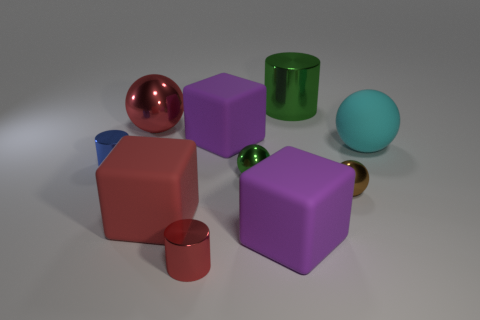Can you describe the lighting in the scene? The scene is lit by a soft, diffused light source from above, creating gentle shadows beneath the objects, indicating the light is not very harsh or direct. How does the lighting affect the appearance of the materials? The diffused lighting enhances the visual textures of the materials, highlighting their reflective qualities and bringing out the richness in their colors. It also gives the objects a slightly matte appearance, reducing glare and allowing the viewer to appreciate the subtleties of their surfaces. 